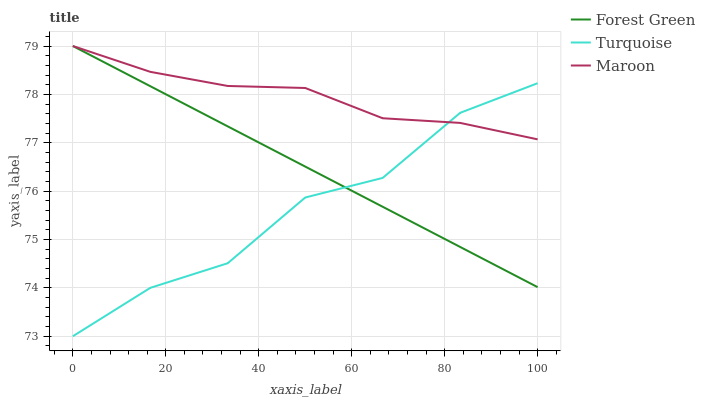Does Turquoise have the minimum area under the curve?
Answer yes or no. Yes. Does Maroon have the maximum area under the curve?
Answer yes or no. Yes. Does Maroon have the minimum area under the curve?
Answer yes or no. No. Does Turquoise have the maximum area under the curve?
Answer yes or no. No. Is Forest Green the smoothest?
Answer yes or no. Yes. Is Turquoise the roughest?
Answer yes or no. Yes. Is Maroon the smoothest?
Answer yes or no. No. Is Maroon the roughest?
Answer yes or no. No. Does Turquoise have the lowest value?
Answer yes or no. Yes. Does Maroon have the lowest value?
Answer yes or no. No. Does Maroon have the highest value?
Answer yes or no. Yes. Does Turquoise have the highest value?
Answer yes or no. No. Does Forest Green intersect Maroon?
Answer yes or no. Yes. Is Forest Green less than Maroon?
Answer yes or no. No. Is Forest Green greater than Maroon?
Answer yes or no. No. 